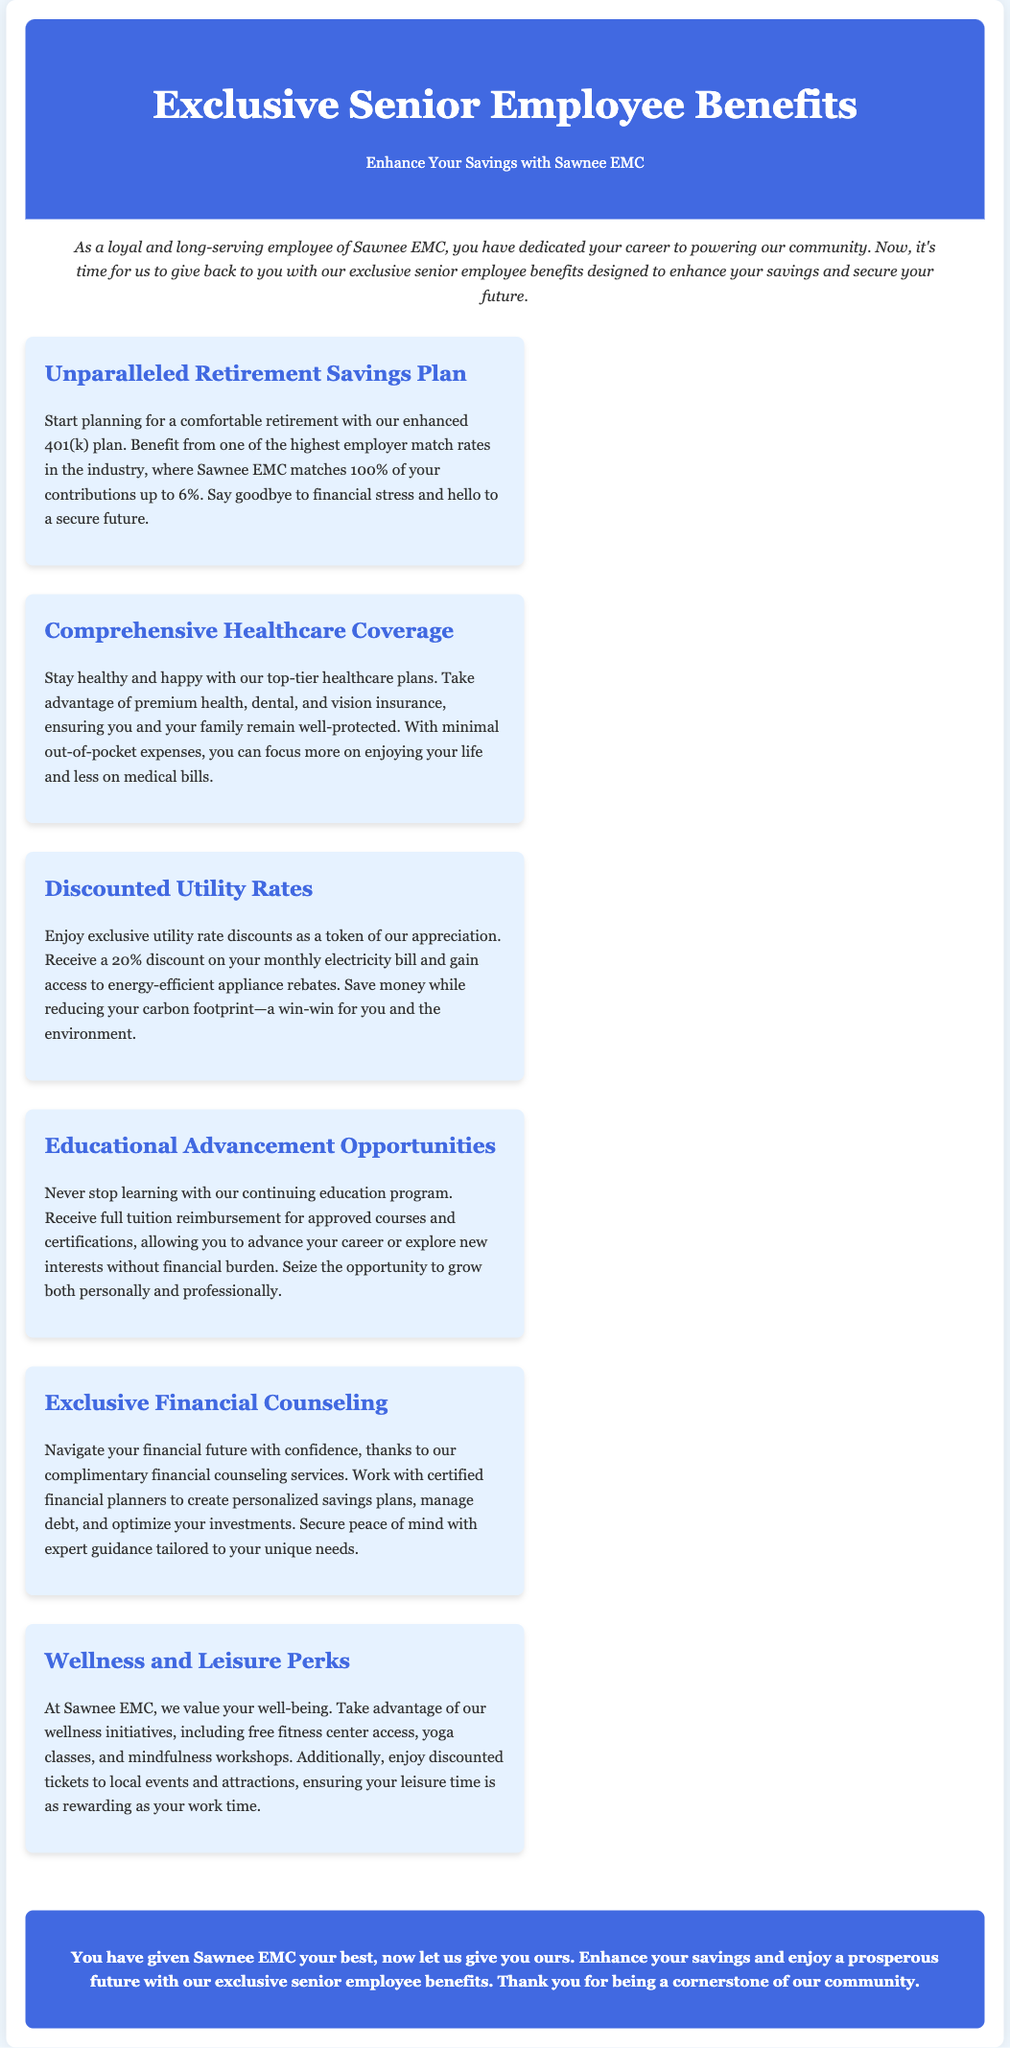What is the name of the organization offering the benefits? The advertisement states that Sawnee EMC is offering the exclusive senior employee benefits.
Answer: Sawnee EMC What percentage does Sawnee EMC match in the enhanced 401(k) plan? The document mentions that Sawnee EMC matches 100% of contributions up to 6%.
Answer: 100% What type of insurance is included in the comprehensive healthcare coverage? The benefits describe premium health, dental, and vision insurance.
Answer: health, dental, and vision insurance What discount is provided on the monthly electricity bill? The advertisement states that employees will receive a 20% discount on their monthly electricity bill.
Answer: 20% What program offers full tuition reimbursement? The document refers to the continuing education program that provides full tuition reimbursement for approved courses.
Answer: continuing education program What is included in the wellness initiatives? The advertisement lists free fitness center access, yoga classes, and mindfulness workshops as part of the wellness initiatives.
Answer: fitness center access, yoga classes, and mindfulness workshops Who can employees work with for financial counseling? The document states that employees can work with certified financial planners for personalized savings plans.
Answer: certified financial planners What is the main goal of the exclusive senior employee benefits? The advertisement emphasizes enhancing employees' savings and securing their future.
Answer: enhance savings and secure future What is the unique offer related to education? The advertisement highlights that employees can receive full tuition reimbursement for approved courses and certifications.
Answer: full tuition reimbursement 